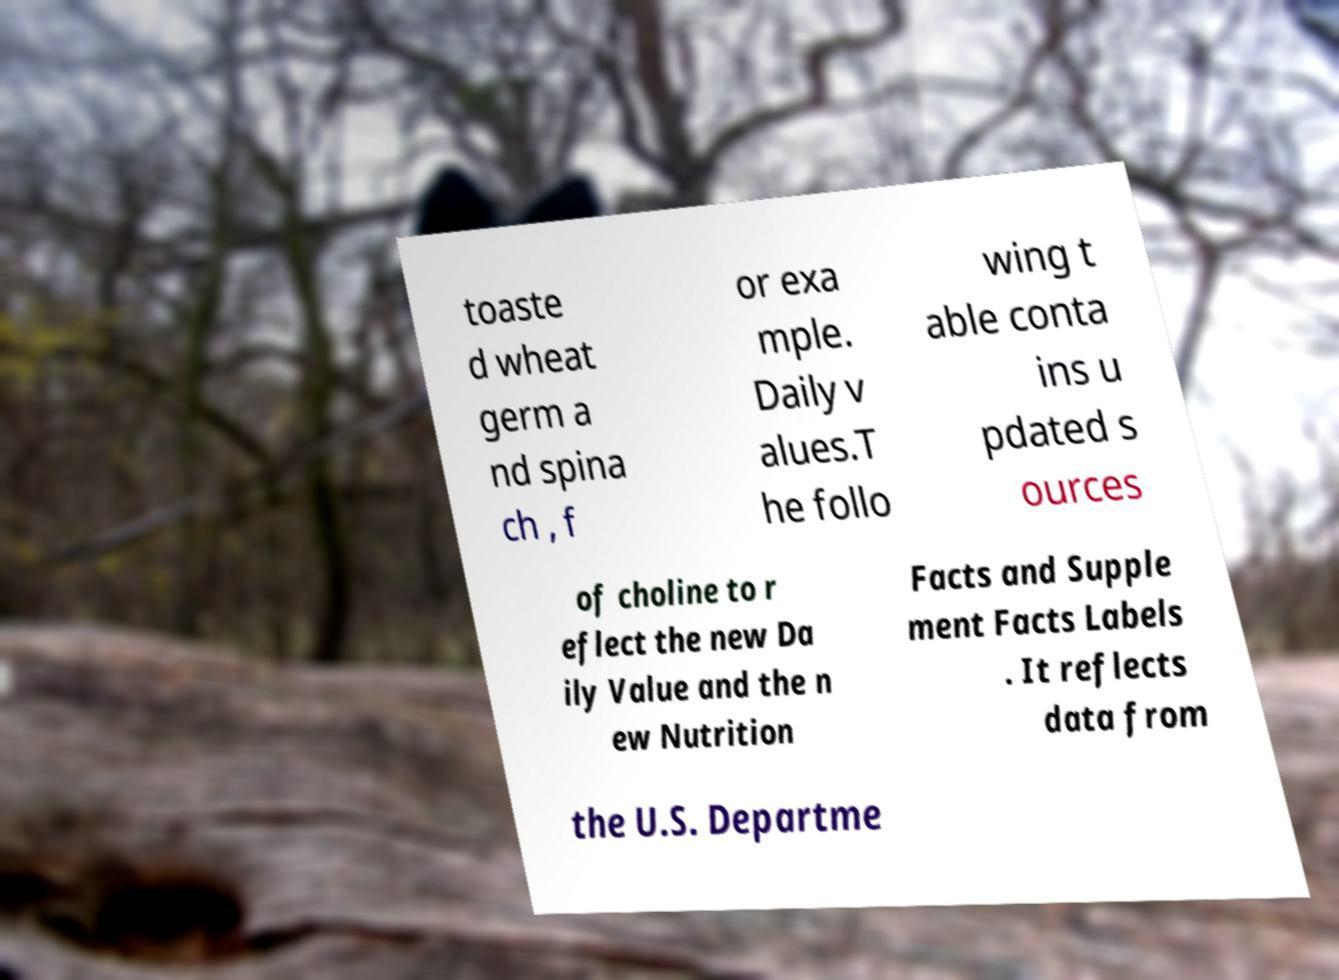What messages or text are displayed in this image? I need them in a readable, typed format. toaste d wheat germ a nd spina ch , f or exa mple. Daily v alues.T he follo wing t able conta ins u pdated s ources of choline to r eflect the new Da ily Value and the n ew Nutrition Facts and Supple ment Facts Labels . It reflects data from the U.S. Departme 